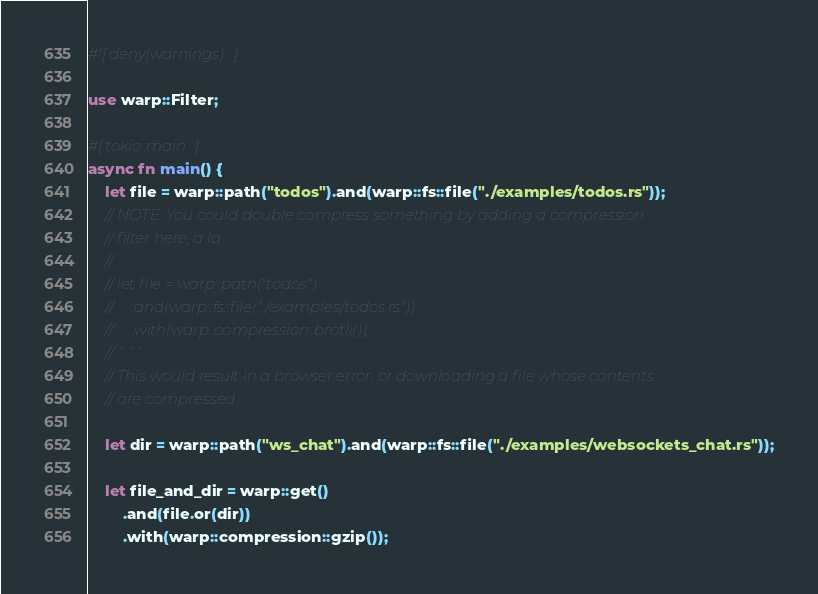Convert code to text. <code><loc_0><loc_0><loc_500><loc_500><_Rust_>#![deny(warnings)]

use warp::Filter;

#[tokio::main]
async fn main() {
    let file = warp::path("todos").and(warp::fs::file("./examples/todos.rs"));
    // NOTE: You could double compress something by adding a compression
    // filter here, a la
    // ```
    // let file = warp::path("todos")
    //     .and(warp::fs::file("./examples/todos.rs"))
    //     .with(warp::compression::brotli());
    // ```
    // This would result in a browser error, or downloading a file whose contents
    // are compressed

    let dir = warp::path("ws_chat").and(warp::fs::file("./examples/websockets_chat.rs"));

    let file_and_dir = warp::get()
        .and(file.or(dir))
        .with(warp::compression::gzip());
</code> 